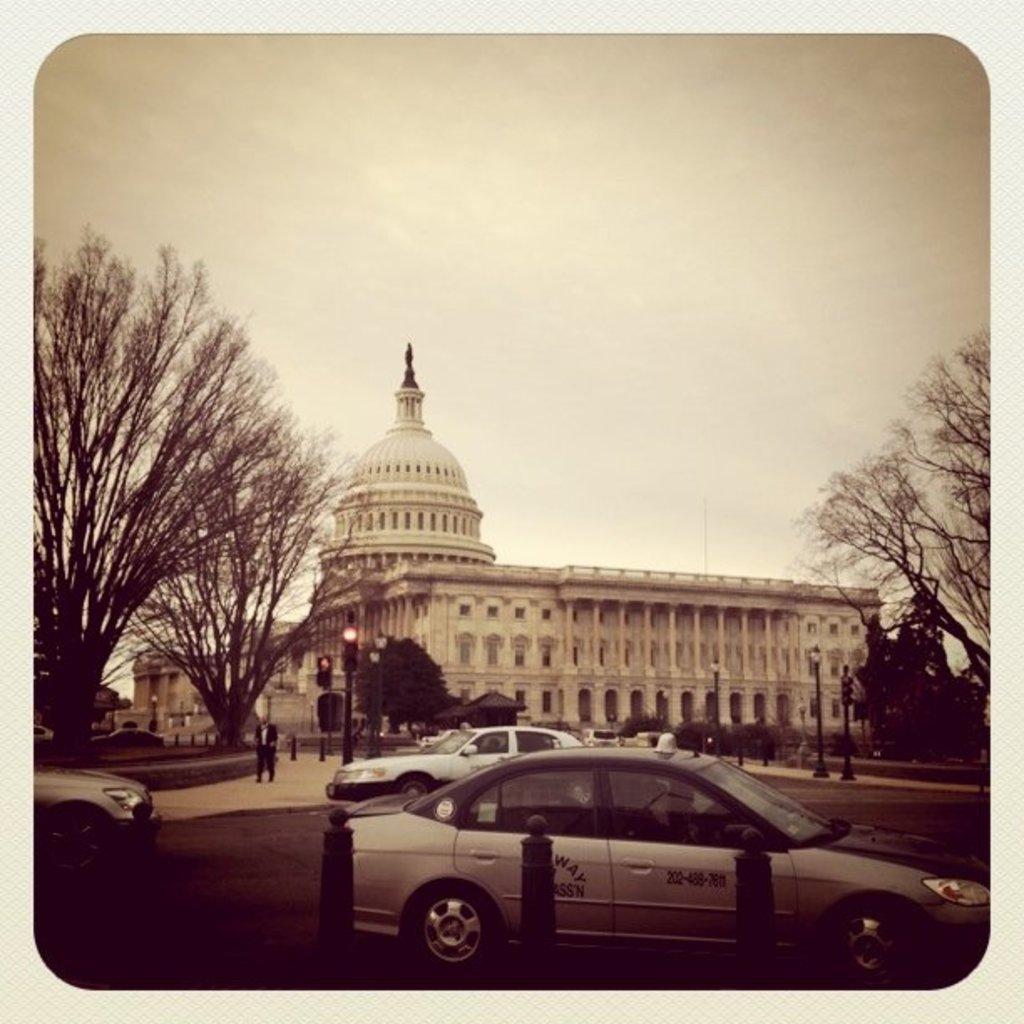How would you summarize this image in a sentence or two? In the foreground I can see vehicles on the road, trees, fence, light poles and a group of people. In the background I can see buildings, pillars, house plants and the sky. This image looks like a photo frame. 